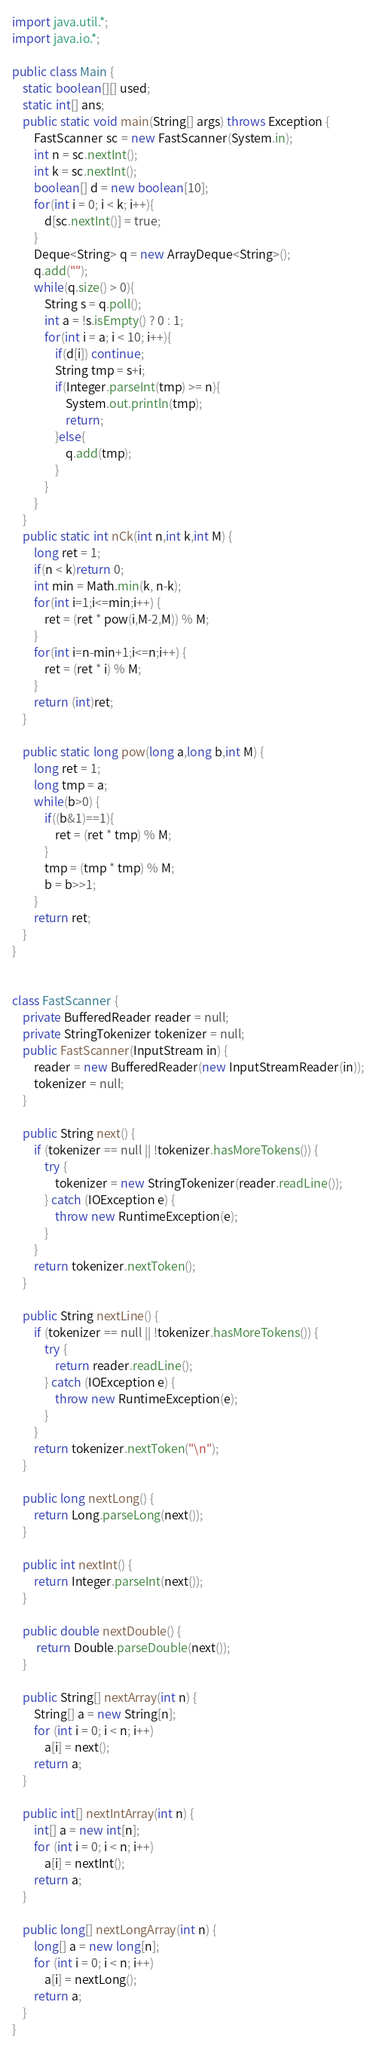Convert code to text. <code><loc_0><loc_0><loc_500><loc_500><_Java_>import java.util.*;
import java.io.*;
 
public class Main {
    static boolean[][] used;
    static int[] ans;
    public static void main(String[] args) throws Exception {
        FastScanner sc = new FastScanner(System.in);
        int n = sc.nextInt();
        int k = sc.nextInt();
        boolean[] d = new boolean[10];
        for(int i = 0; i < k; i++){
            d[sc.nextInt()] = true;
        }
        Deque<String> q = new ArrayDeque<String>();
        q.add("");
        while(q.size() > 0){
            String s = q.poll();
            int a = !s.isEmpty() ? 0 : 1;
            for(int i = a; i < 10; i++){
                if(d[i]) continue;
                String tmp = s+i;
                if(Integer.parseInt(tmp) >= n){
                    System.out.println(tmp);
                    return;
                }else{
                    q.add(tmp);
                }
            }
        }
    }
    public static int nCk(int n,int k,int M) {
        long ret = 1;
        if(n < k)return 0;
        int min = Math.min(k, n-k);
        for(int i=1;i<=min;i++) {
            ret = (ret * pow(i,M-2,M)) % M;
        }
        for(int i=n-min+1;i<=n;i++) {
            ret = (ret * i) % M;
        }
        return (int)ret;
    }

    public static long pow(long a,long b,int M) {
        long ret = 1;
        long tmp = a;
        while(b>0) {
            if((b&1)==1){
                ret = (ret * tmp) % M;
            }
            tmp = (tmp * tmp) % M;
            b = b>>1;
        }
        return ret;
    }
}


class FastScanner {
    private BufferedReader reader = null;
    private StringTokenizer tokenizer = null;
    public FastScanner(InputStream in) {
        reader = new BufferedReader(new InputStreamReader(in));
        tokenizer = null;
    }

    public String next() {
        if (tokenizer == null || !tokenizer.hasMoreTokens()) {
            try {
                tokenizer = new StringTokenizer(reader.readLine());
            } catch (IOException e) {
                throw new RuntimeException(e);
            }
        }
        return tokenizer.nextToken();
    }

    public String nextLine() {
        if (tokenizer == null || !tokenizer.hasMoreTokens()) {
            try {
                return reader.readLine();
            } catch (IOException e) {
                throw new RuntimeException(e);
            }
        }
        return tokenizer.nextToken("\n");
    }

    public long nextLong() {
        return Long.parseLong(next());
    }

    public int nextInt() {
        return Integer.parseInt(next());
    }

    public double nextDouble() {
         return Double.parseDouble(next());
    }
    
    public String[] nextArray(int n) {
        String[] a = new String[n];
        for (int i = 0; i < n; i++)
            a[i] = next();
        return a;
    }

    public int[] nextIntArray(int n) {
        int[] a = new int[n];
        for (int i = 0; i < n; i++)
            a[i] = nextInt();
        return a;
    }

    public long[] nextLongArray(int n) {
        long[] a = new long[n];
        for (int i = 0; i < n; i++)
            a[i] = nextLong();
        return a;
    } 
}
</code> 